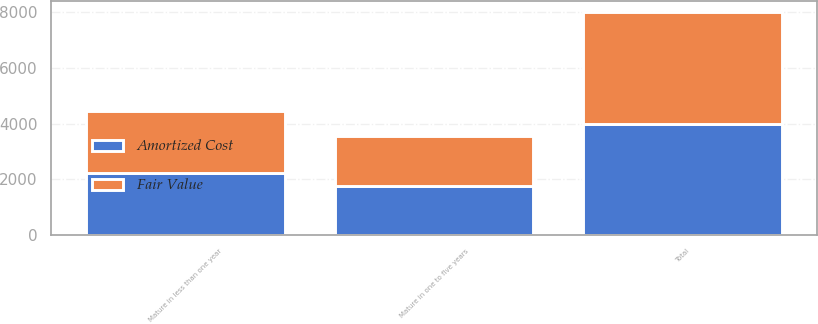Convert chart. <chart><loc_0><loc_0><loc_500><loc_500><stacked_bar_chart><ecel><fcel>Mature in less than one year<fcel>Mature in one to five years<fcel>Total<nl><fcel>Fair Value<fcel>2230.2<fcel>1776.3<fcel>4006.5<nl><fcel>Amortized Cost<fcel>2224.6<fcel>1771.3<fcel>3995.9<nl></chart> 